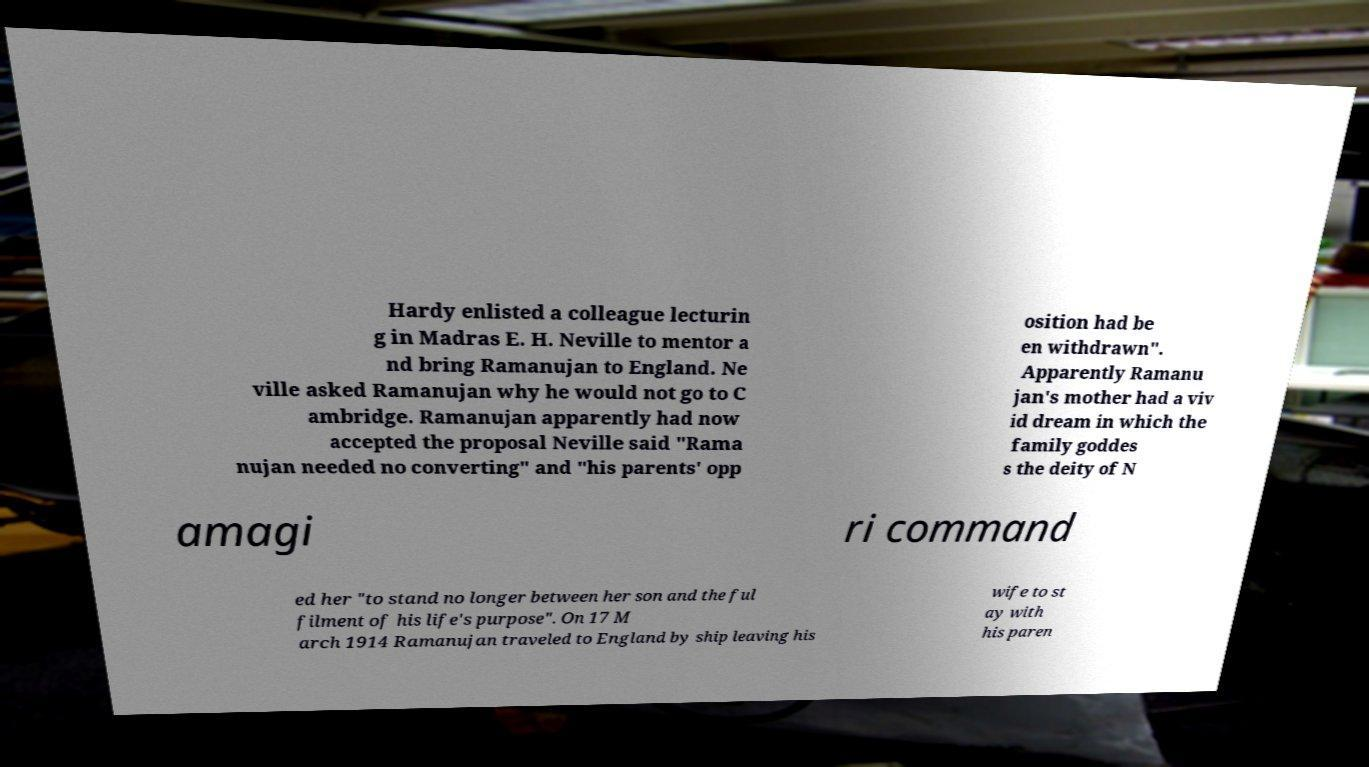Could you assist in decoding the text presented in this image and type it out clearly? Hardy enlisted a colleague lecturin g in Madras E. H. Neville to mentor a nd bring Ramanujan to England. Ne ville asked Ramanujan why he would not go to C ambridge. Ramanujan apparently had now accepted the proposal Neville said "Rama nujan needed no converting" and "his parents' opp osition had be en withdrawn". Apparently Ramanu jan's mother had a viv id dream in which the family goddes s the deity of N amagi ri command ed her "to stand no longer between her son and the ful filment of his life's purpose". On 17 M arch 1914 Ramanujan traveled to England by ship leaving his wife to st ay with his paren 